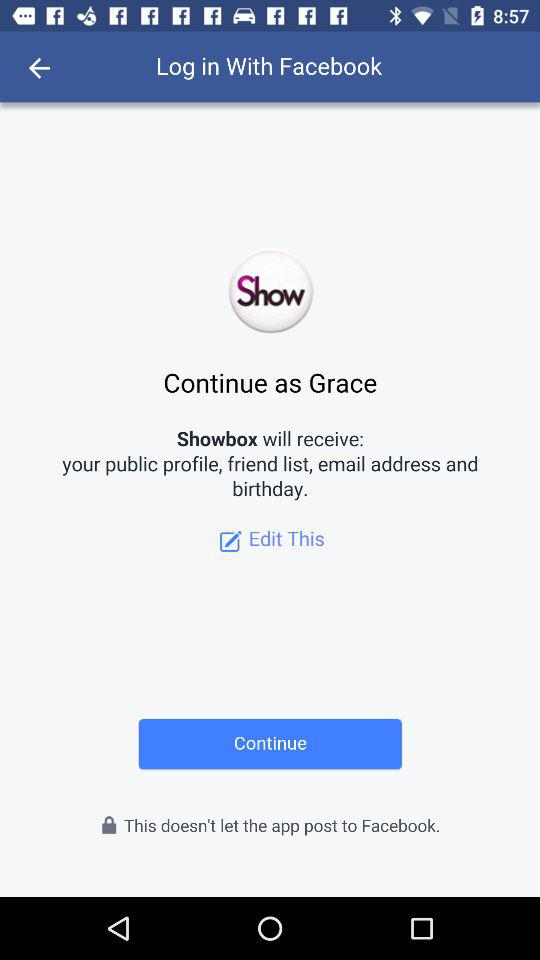Which option is selected?
When the provided information is insufficient, respond with <no answer>. <no answer> 